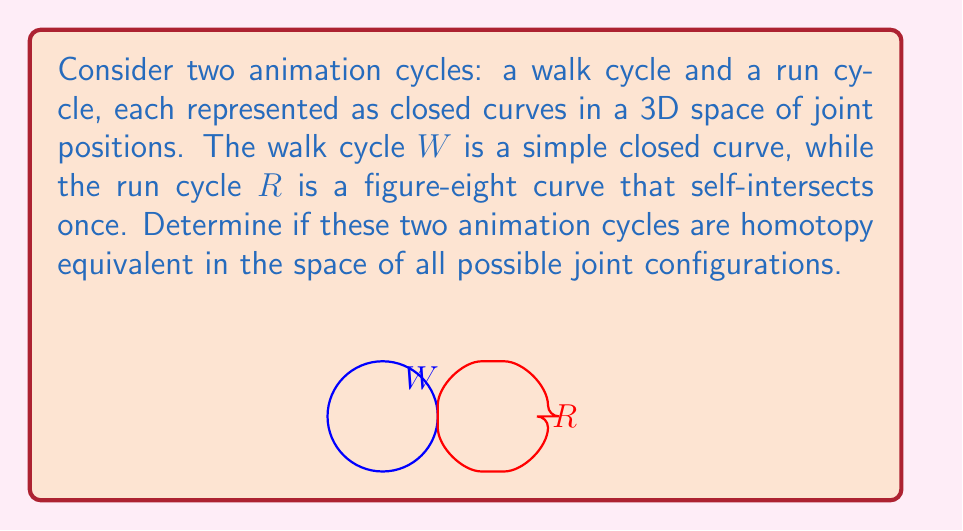Can you solve this math problem? To evaluate the homotopy equivalence of these two animation cycles, we need to consider their topological properties in the space of all possible joint configurations. Let's approach this step-by-step:

1) First, recall that two spaces are homotopy equivalent if one can be continuously deformed into the other without tearing or gluing.

2) The walk cycle $W$ is represented by a simple closed curve. Topologically, this is equivalent to a circle $S^1$.

3) The run cycle $R$ is represented by a figure-eight curve. Topologically, this is equivalent to a wedge sum of two circles, often denoted as $S^1 \vee S^1$.

4) In the 3D space of joint positions, both curves can be continuously deformed without intersecting the boundaries of the configuration space. This means we're essentially working in $\mathbb{R}^3$.

5) In $\mathbb{R}^3$ (or any space of dimension 3 or higher), a figure-eight can be "untangled" into two separate loops without breaking the curve. This is because we have enough dimensions to move one loop "around" the other.

6) However, these two separate loops cannot be merged into a single loop without breaking and re-gluing the curve, which is not allowed in a homotopy.

7) Mathematically, we can express this as:

   $$\pi_1(S^1) \cong \mathbb{Z} \neq \mathbb{Z} * \mathbb{Z} \cong \pi_1(S^1 \vee S^1)$$

   where $\pi_1$ denotes the fundamental group and $*$ is the free product of groups.

8) The fundamental groups being different implies that $W$ and $R$ are not homotopy equivalent.

From an animation perspective, this means that the walk cycle and run cycle cannot be smoothly transformed into each other without fundamentally changing the structure of the movement.
Answer: Not homotopy equivalent 